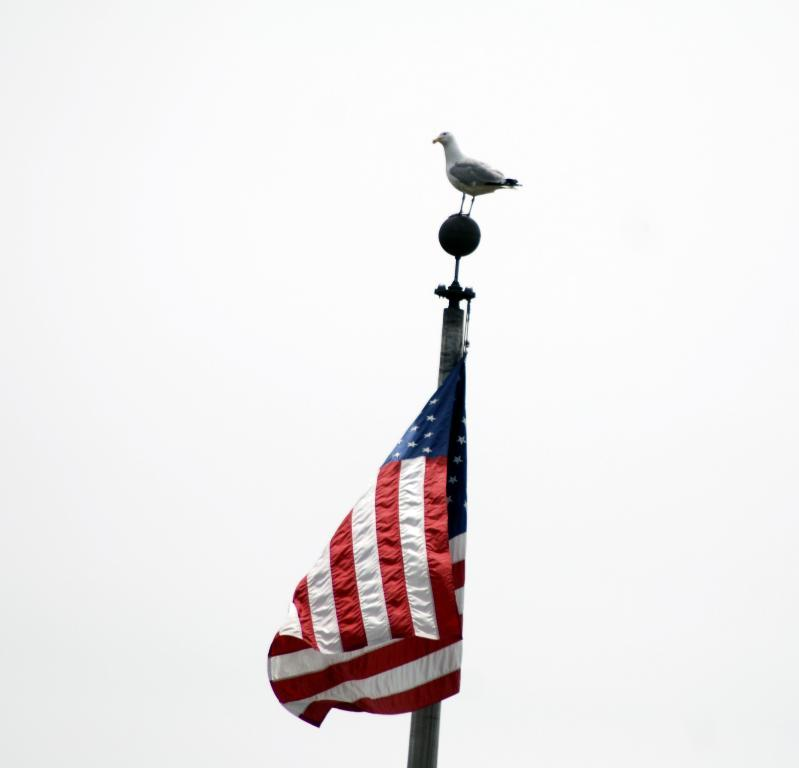What is the main object in the image? There is a flag in the image. Is there anything else attached to the flag? Yes, a bird is present on the flag rod. What color is the background of the image? The background of the image is white. What type of substance can be seen dripping from the bird on the flag rod in the image? There is no substance dripping from the bird on the flag rod in the image. Is there a church visible in the image? No, there is no church present in the image. Can you see a bomb in the image? No, there is no bomb present in the image. 